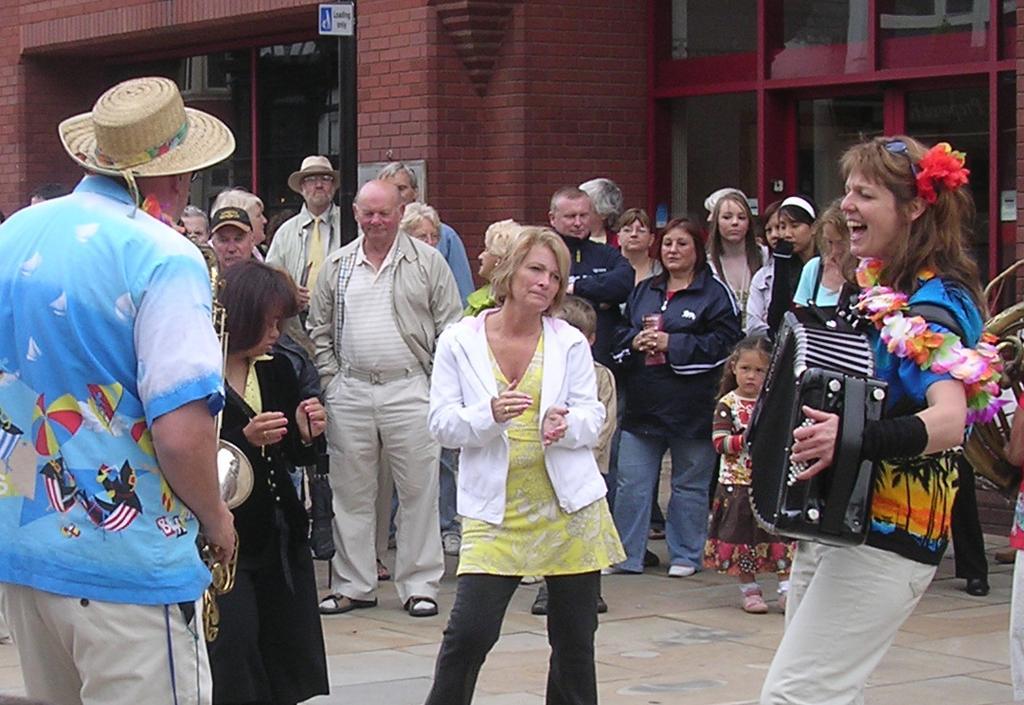Please provide a concise description of this image. In this image there are group of people who are standing and on the right side there is one woman who is standing and she is holding a musical instrument, it seems that she is singing. On the background there is a wall and some glass windows are there on the right side and left side, and on the left side there is one man who is standing and he is wearing a hat and he is holding a saxophone. 